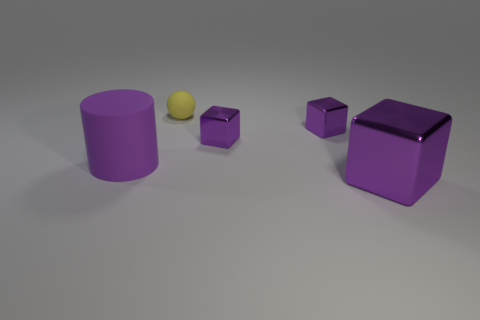Are the objects arranged in a particular pattern? The objects are placed with a sense of spacing that suggests no particular pattern; they are randomly spaced with varying distances between them. 